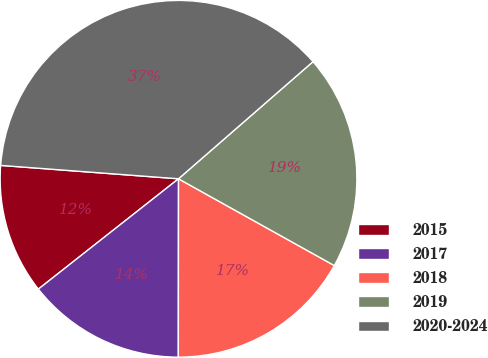<chart> <loc_0><loc_0><loc_500><loc_500><pie_chart><fcel>2015<fcel>2017<fcel>2018<fcel>2019<fcel>2020-2024<nl><fcel>11.81%<fcel>14.37%<fcel>16.93%<fcel>19.49%<fcel>37.4%<nl></chart> 